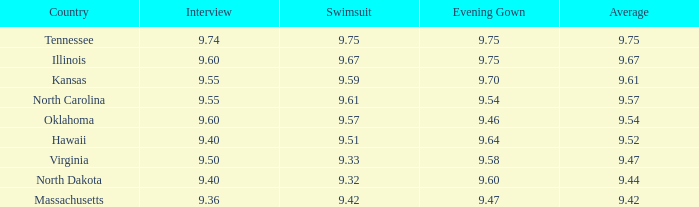Which country had an interview score of 9.40 and average of 9.44? North Dakota. 